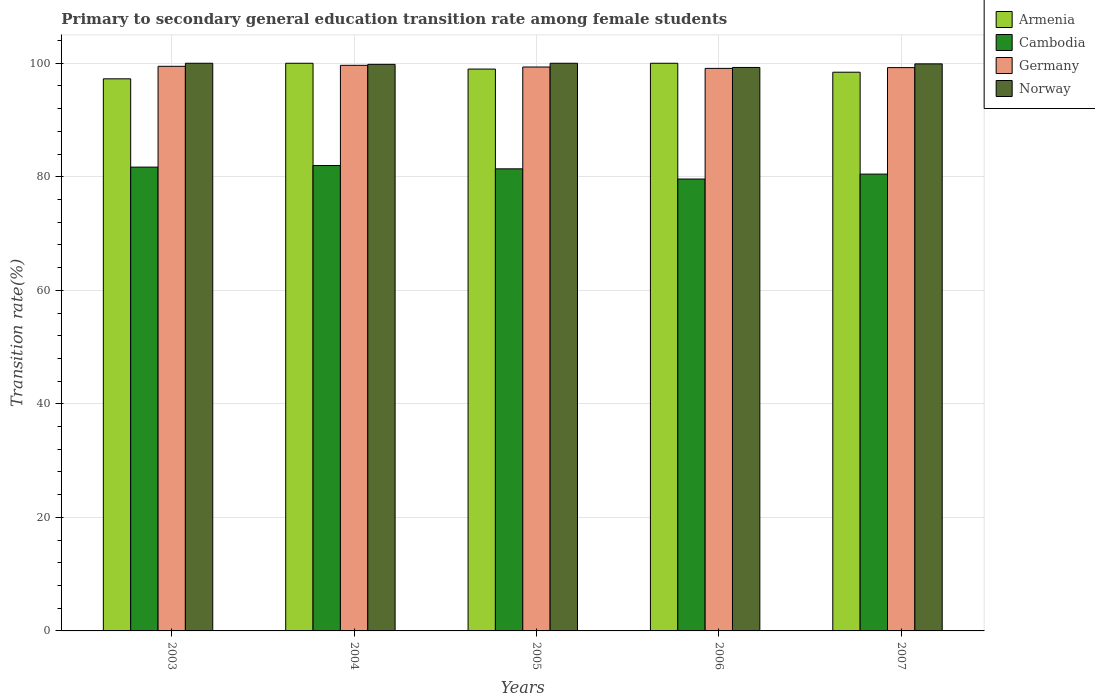How many different coloured bars are there?
Offer a very short reply. 4. How many groups of bars are there?
Offer a very short reply. 5. What is the label of the 5th group of bars from the left?
Your answer should be very brief. 2007. Across all years, what is the minimum transition rate in Cambodia?
Keep it short and to the point. 79.6. In which year was the transition rate in Armenia maximum?
Your response must be concise. 2004. What is the total transition rate in Germany in the graph?
Offer a terse response. 496.77. What is the difference between the transition rate in Armenia in 2006 and that in 2007?
Provide a succinct answer. 1.58. What is the difference between the transition rate in Armenia in 2005 and the transition rate in Norway in 2003?
Provide a short and direct response. -1.03. What is the average transition rate in Norway per year?
Your answer should be compact. 99.79. In the year 2005, what is the difference between the transition rate in Norway and transition rate in Cambodia?
Provide a short and direct response. 18.6. In how many years, is the transition rate in Armenia greater than 40 %?
Make the answer very short. 5. What is the ratio of the transition rate in Germany in 2006 to that in 2007?
Offer a very short reply. 1. Is the transition rate in Cambodia in 2003 less than that in 2005?
Make the answer very short. No. Is the difference between the transition rate in Norway in 2004 and 2005 greater than the difference between the transition rate in Cambodia in 2004 and 2005?
Your response must be concise. No. What is the difference between the highest and the second highest transition rate in Cambodia?
Your answer should be very brief. 0.28. What is the difference between the highest and the lowest transition rate in Germany?
Offer a very short reply. 0.54. In how many years, is the transition rate in Germany greater than the average transition rate in Germany taken over all years?
Ensure brevity in your answer.  2. Is the sum of the transition rate in Germany in 2003 and 2004 greater than the maximum transition rate in Armenia across all years?
Your response must be concise. Yes. Is it the case that in every year, the sum of the transition rate in Armenia and transition rate in Norway is greater than the sum of transition rate in Germany and transition rate in Cambodia?
Offer a very short reply. Yes. What does the 2nd bar from the left in 2004 represents?
Provide a succinct answer. Cambodia. What does the 3rd bar from the right in 2005 represents?
Make the answer very short. Cambodia. Is it the case that in every year, the sum of the transition rate in Norway and transition rate in Germany is greater than the transition rate in Cambodia?
Offer a terse response. Yes. How many bars are there?
Your answer should be compact. 20. Are all the bars in the graph horizontal?
Make the answer very short. No. How many years are there in the graph?
Give a very brief answer. 5. Are the values on the major ticks of Y-axis written in scientific E-notation?
Your answer should be very brief. No. Where does the legend appear in the graph?
Your answer should be very brief. Top right. How are the legend labels stacked?
Your answer should be compact. Vertical. What is the title of the graph?
Your answer should be compact. Primary to secondary general education transition rate among female students. Does "Belize" appear as one of the legend labels in the graph?
Offer a terse response. No. What is the label or title of the Y-axis?
Your answer should be compact. Transition rate(%). What is the Transition rate(%) of Armenia in 2003?
Make the answer very short. 97.26. What is the Transition rate(%) of Cambodia in 2003?
Provide a succinct answer. 81.7. What is the Transition rate(%) of Germany in 2003?
Keep it short and to the point. 99.46. What is the Transition rate(%) of Norway in 2003?
Your answer should be compact. 100. What is the Transition rate(%) in Cambodia in 2004?
Make the answer very short. 81.98. What is the Transition rate(%) of Germany in 2004?
Give a very brief answer. 99.64. What is the Transition rate(%) in Norway in 2004?
Give a very brief answer. 99.81. What is the Transition rate(%) of Armenia in 2005?
Make the answer very short. 98.97. What is the Transition rate(%) of Cambodia in 2005?
Ensure brevity in your answer.  81.4. What is the Transition rate(%) in Germany in 2005?
Your answer should be compact. 99.34. What is the Transition rate(%) in Norway in 2005?
Provide a succinct answer. 100. What is the Transition rate(%) of Armenia in 2006?
Your response must be concise. 100. What is the Transition rate(%) of Cambodia in 2006?
Offer a very short reply. 79.6. What is the Transition rate(%) in Germany in 2006?
Provide a short and direct response. 99.1. What is the Transition rate(%) in Norway in 2006?
Offer a terse response. 99.26. What is the Transition rate(%) of Armenia in 2007?
Your answer should be very brief. 98.42. What is the Transition rate(%) of Cambodia in 2007?
Make the answer very short. 80.47. What is the Transition rate(%) of Germany in 2007?
Your answer should be very brief. 99.23. What is the Transition rate(%) of Norway in 2007?
Ensure brevity in your answer.  99.89. Across all years, what is the maximum Transition rate(%) in Cambodia?
Provide a short and direct response. 81.98. Across all years, what is the maximum Transition rate(%) of Germany?
Give a very brief answer. 99.64. Across all years, what is the maximum Transition rate(%) of Norway?
Make the answer very short. 100. Across all years, what is the minimum Transition rate(%) in Armenia?
Offer a very short reply. 97.26. Across all years, what is the minimum Transition rate(%) of Cambodia?
Your answer should be very brief. 79.6. Across all years, what is the minimum Transition rate(%) in Germany?
Offer a terse response. 99.1. Across all years, what is the minimum Transition rate(%) in Norway?
Provide a short and direct response. 99.26. What is the total Transition rate(%) of Armenia in the graph?
Provide a succinct answer. 494.66. What is the total Transition rate(%) of Cambodia in the graph?
Ensure brevity in your answer.  405.17. What is the total Transition rate(%) of Germany in the graph?
Your answer should be compact. 496.77. What is the total Transition rate(%) in Norway in the graph?
Provide a succinct answer. 498.96. What is the difference between the Transition rate(%) in Armenia in 2003 and that in 2004?
Keep it short and to the point. -2.74. What is the difference between the Transition rate(%) of Cambodia in 2003 and that in 2004?
Offer a very short reply. -0.28. What is the difference between the Transition rate(%) of Germany in 2003 and that in 2004?
Provide a succinct answer. -0.18. What is the difference between the Transition rate(%) in Norway in 2003 and that in 2004?
Your answer should be very brief. 0.19. What is the difference between the Transition rate(%) of Armenia in 2003 and that in 2005?
Give a very brief answer. -1.72. What is the difference between the Transition rate(%) in Cambodia in 2003 and that in 2005?
Offer a very short reply. 0.3. What is the difference between the Transition rate(%) in Germany in 2003 and that in 2005?
Offer a terse response. 0.12. What is the difference between the Transition rate(%) of Armenia in 2003 and that in 2006?
Your answer should be compact. -2.74. What is the difference between the Transition rate(%) in Cambodia in 2003 and that in 2006?
Make the answer very short. 2.1. What is the difference between the Transition rate(%) in Germany in 2003 and that in 2006?
Provide a succinct answer. 0.36. What is the difference between the Transition rate(%) of Norway in 2003 and that in 2006?
Offer a very short reply. 0.74. What is the difference between the Transition rate(%) of Armenia in 2003 and that in 2007?
Offer a terse response. -1.17. What is the difference between the Transition rate(%) in Cambodia in 2003 and that in 2007?
Ensure brevity in your answer.  1.23. What is the difference between the Transition rate(%) of Germany in 2003 and that in 2007?
Offer a very short reply. 0.23. What is the difference between the Transition rate(%) of Norway in 2003 and that in 2007?
Provide a short and direct response. 0.11. What is the difference between the Transition rate(%) of Armenia in 2004 and that in 2005?
Provide a succinct answer. 1.03. What is the difference between the Transition rate(%) in Cambodia in 2004 and that in 2005?
Offer a terse response. 0.58. What is the difference between the Transition rate(%) of Germany in 2004 and that in 2005?
Offer a very short reply. 0.3. What is the difference between the Transition rate(%) in Norway in 2004 and that in 2005?
Give a very brief answer. -0.19. What is the difference between the Transition rate(%) in Cambodia in 2004 and that in 2006?
Your response must be concise. 2.38. What is the difference between the Transition rate(%) of Germany in 2004 and that in 2006?
Provide a short and direct response. 0.54. What is the difference between the Transition rate(%) of Norway in 2004 and that in 2006?
Make the answer very short. 0.55. What is the difference between the Transition rate(%) in Armenia in 2004 and that in 2007?
Make the answer very short. 1.58. What is the difference between the Transition rate(%) of Cambodia in 2004 and that in 2007?
Provide a short and direct response. 1.51. What is the difference between the Transition rate(%) in Germany in 2004 and that in 2007?
Keep it short and to the point. 0.41. What is the difference between the Transition rate(%) of Norway in 2004 and that in 2007?
Make the answer very short. -0.09. What is the difference between the Transition rate(%) in Armenia in 2005 and that in 2006?
Your answer should be very brief. -1.03. What is the difference between the Transition rate(%) in Cambodia in 2005 and that in 2006?
Your response must be concise. 1.8. What is the difference between the Transition rate(%) in Germany in 2005 and that in 2006?
Your response must be concise. 0.24. What is the difference between the Transition rate(%) in Norway in 2005 and that in 2006?
Provide a succinct answer. 0.74. What is the difference between the Transition rate(%) of Armenia in 2005 and that in 2007?
Provide a succinct answer. 0.55. What is the difference between the Transition rate(%) of Cambodia in 2005 and that in 2007?
Give a very brief answer. 0.93. What is the difference between the Transition rate(%) of Germany in 2005 and that in 2007?
Ensure brevity in your answer.  0.11. What is the difference between the Transition rate(%) in Norway in 2005 and that in 2007?
Give a very brief answer. 0.11. What is the difference between the Transition rate(%) of Armenia in 2006 and that in 2007?
Provide a succinct answer. 1.58. What is the difference between the Transition rate(%) in Cambodia in 2006 and that in 2007?
Give a very brief answer. -0.87. What is the difference between the Transition rate(%) of Germany in 2006 and that in 2007?
Give a very brief answer. -0.13. What is the difference between the Transition rate(%) of Norway in 2006 and that in 2007?
Offer a terse response. -0.63. What is the difference between the Transition rate(%) in Armenia in 2003 and the Transition rate(%) in Cambodia in 2004?
Ensure brevity in your answer.  15.27. What is the difference between the Transition rate(%) of Armenia in 2003 and the Transition rate(%) of Germany in 2004?
Provide a short and direct response. -2.38. What is the difference between the Transition rate(%) in Armenia in 2003 and the Transition rate(%) in Norway in 2004?
Your response must be concise. -2.55. What is the difference between the Transition rate(%) of Cambodia in 2003 and the Transition rate(%) of Germany in 2004?
Keep it short and to the point. -17.93. What is the difference between the Transition rate(%) in Cambodia in 2003 and the Transition rate(%) in Norway in 2004?
Your answer should be compact. -18.1. What is the difference between the Transition rate(%) in Germany in 2003 and the Transition rate(%) in Norway in 2004?
Your answer should be compact. -0.35. What is the difference between the Transition rate(%) in Armenia in 2003 and the Transition rate(%) in Cambodia in 2005?
Make the answer very short. 15.86. What is the difference between the Transition rate(%) of Armenia in 2003 and the Transition rate(%) of Germany in 2005?
Keep it short and to the point. -2.08. What is the difference between the Transition rate(%) of Armenia in 2003 and the Transition rate(%) of Norway in 2005?
Ensure brevity in your answer.  -2.74. What is the difference between the Transition rate(%) of Cambodia in 2003 and the Transition rate(%) of Germany in 2005?
Offer a very short reply. -17.64. What is the difference between the Transition rate(%) in Cambodia in 2003 and the Transition rate(%) in Norway in 2005?
Offer a terse response. -18.3. What is the difference between the Transition rate(%) of Germany in 2003 and the Transition rate(%) of Norway in 2005?
Provide a succinct answer. -0.54. What is the difference between the Transition rate(%) of Armenia in 2003 and the Transition rate(%) of Cambodia in 2006?
Your response must be concise. 17.65. What is the difference between the Transition rate(%) in Armenia in 2003 and the Transition rate(%) in Germany in 2006?
Your answer should be very brief. -1.84. What is the difference between the Transition rate(%) of Armenia in 2003 and the Transition rate(%) of Norway in 2006?
Ensure brevity in your answer.  -2. What is the difference between the Transition rate(%) of Cambodia in 2003 and the Transition rate(%) of Germany in 2006?
Ensure brevity in your answer.  -17.4. What is the difference between the Transition rate(%) of Cambodia in 2003 and the Transition rate(%) of Norway in 2006?
Give a very brief answer. -17.56. What is the difference between the Transition rate(%) in Germany in 2003 and the Transition rate(%) in Norway in 2006?
Give a very brief answer. 0.2. What is the difference between the Transition rate(%) in Armenia in 2003 and the Transition rate(%) in Cambodia in 2007?
Provide a succinct answer. 16.79. What is the difference between the Transition rate(%) of Armenia in 2003 and the Transition rate(%) of Germany in 2007?
Make the answer very short. -1.97. What is the difference between the Transition rate(%) in Armenia in 2003 and the Transition rate(%) in Norway in 2007?
Ensure brevity in your answer.  -2.63. What is the difference between the Transition rate(%) of Cambodia in 2003 and the Transition rate(%) of Germany in 2007?
Offer a terse response. -17.53. What is the difference between the Transition rate(%) of Cambodia in 2003 and the Transition rate(%) of Norway in 2007?
Give a very brief answer. -18.19. What is the difference between the Transition rate(%) in Germany in 2003 and the Transition rate(%) in Norway in 2007?
Give a very brief answer. -0.43. What is the difference between the Transition rate(%) of Armenia in 2004 and the Transition rate(%) of Cambodia in 2005?
Your answer should be very brief. 18.6. What is the difference between the Transition rate(%) in Armenia in 2004 and the Transition rate(%) in Germany in 2005?
Your answer should be compact. 0.66. What is the difference between the Transition rate(%) in Cambodia in 2004 and the Transition rate(%) in Germany in 2005?
Offer a terse response. -17.36. What is the difference between the Transition rate(%) of Cambodia in 2004 and the Transition rate(%) of Norway in 2005?
Make the answer very short. -18.02. What is the difference between the Transition rate(%) of Germany in 2004 and the Transition rate(%) of Norway in 2005?
Make the answer very short. -0.36. What is the difference between the Transition rate(%) of Armenia in 2004 and the Transition rate(%) of Cambodia in 2006?
Your answer should be compact. 20.4. What is the difference between the Transition rate(%) in Armenia in 2004 and the Transition rate(%) in Germany in 2006?
Offer a very short reply. 0.9. What is the difference between the Transition rate(%) in Armenia in 2004 and the Transition rate(%) in Norway in 2006?
Your answer should be very brief. 0.74. What is the difference between the Transition rate(%) in Cambodia in 2004 and the Transition rate(%) in Germany in 2006?
Provide a succinct answer. -17.11. What is the difference between the Transition rate(%) of Cambodia in 2004 and the Transition rate(%) of Norway in 2006?
Your response must be concise. -17.28. What is the difference between the Transition rate(%) in Germany in 2004 and the Transition rate(%) in Norway in 2006?
Offer a very short reply. 0.38. What is the difference between the Transition rate(%) in Armenia in 2004 and the Transition rate(%) in Cambodia in 2007?
Ensure brevity in your answer.  19.53. What is the difference between the Transition rate(%) in Armenia in 2004 and the Transition rate(%) in Germany in 2007?
Offer a terse response. 0.77. What is the difference between the Transition rate(%) of Armenia in 2004 and the Transition rate(%) of Norway in 2007?
Offer a terse response. 0.11. What is the difference between the Transition rate(%) of Cambodia in 2004 and the Transition rate(%) of Germany in 2007?
Your response must be concise. -17.25. What is the difference between the Transition rate(%) in Cambodia in 2004 and the Transition rate(%) in Norway in 2007?
Your answer should be very brief. -17.91. What is the difference between the Transition rate(%) of Germany in 2004 and the Transition rate(%) of Norway in 2007?
Offer a terse response. -0.26. What is the difference between the Transition rate(%) of Armenia in 2005 and the Transition rate(%) of Cambodia in 2006?
Your response must be concise. 19.37. What is the difference between the Transition rate(%) of Armenia in 2005 and the Transition rate(%) of Germany in 2006?
Offer a very short reply. -0.12. What is the difference between the Transition rate(%) of Armenia in 2005 and the Transition rate(%) of Norway in 2006?
Your answer should be very brief. -0.28. What is the difference between the Transition rate(%) of Cambodia in 2005 and the Transition rate(%) of Germany in 2006?
Keep it short and to the point. -17.7. What is the difference between the Transition rate(%) in Cambodia in 2005 and the Transition rate(%) in Norway in 2006?
Ensure brevity in your answer.  -17.86. What is the difference between the Transition rate(%) of Germany in 2005 and the Transition rate(%) of Norway in 2006?
Your response must be concise. 0.08. What is the difference between the Transition rate(%) of Armenia in 2005 and the Transition rate(%) of Cambodia in 2007?
Provide a succinct answer. 18.5. What is the difference between the Transition rate(%) in Armenia in 2005 and the Transition rate(%) in Germany in 2007?
Provide a short and direct response. -0.26. What is the difference between the Transition rate(%) of Armenia in 2005 and the Transition rate(%) of Norway in 2007?
Your response must be concise. -0.92. What is the difference between the Transition rate(%) in Cambodia in 2005 and the Transition rate(%) in Germany in 2007?
Offer a terse response. -17.83. What is the difference between the Transition rate(%) of Cambodia in 2005 and the Transition rate(%) of Norway in 2007?
Your response must be concise. -18.49. What is the difference between the Transition rate(%) in Germany in 2005 and the Transition rate(%) in Norway in 2007?
Your answer should be compact. -0.55. What is the difference between the Transition rate(%) of Armenia in 2006 and the Transition rate(%) of Cambodia in 2007?
Make the answer very short. 19.53. What is the difference between the Transition rate(%) in Armenia in 2006 and the Transition rate(%) in Germany in 2007?
Your answer should be very brief. 0.77. What is the difference between the Transition rate(%) of Armenia in 2006 and the Transition rate(%) of Norway in 2007?
Make the answer very short. 0.11. What is the difference between the Transition rate(%) in Cambodia in 2006 and the Transition rate(%) in Germany in 2007?
Provide a short and direct response. -19.63. What is the difference between the Transition rate(%) of Cambodia in 2006 and the Transition rate(%) of Norway in 2007?
Your answer should be very brief. -20.29. What is the difference between the Transition rate(%) in Germany in 2006 and the Transition rate(%) in Norway in 2007?
Keep it short and to the point. -0.79. What is the average Transition rate(%) of Armenia per year?
Offer a terse response. 98.93. What is the average Transition rate(%) of Cambodia per year?
Provide a succinct answer. 81.03. What is the average Transition rate(%) of Germany per year?
Provide a short and direct response. 99.35. What is the average Transition rate(%) in Norway per year?
Provide a succinct answer. 99.79. In the year 2003, what is the difference between the Transition rate(%) of Armenia and Transition rate(%) of Cambodia?
Ensure brevity in your answer.  15.55. In the year 2003, what is the difference between the Transition rate(%) in Armenia and Transition rate(%) in Germany?
Your response must be concise. -2.2. In the year 2003, what is the difference between the Transition rate(%) of Armenia and Transition rate(%) of Norway?
Your answer should be very brief. -2.74. In the year 2003, what is the difference between the Transition rate(%) of Cambodia and Transition rate(%) of Germany?
Keep it short and to the point. -17.76. In the year 2003, what is the difference between the Transition rate(%) of Cambodia and Transition rate(%) of Norway?
Your answer should be very brief. -18.3. In the year 2003, what is the difference between the Transition rate(%) in Germany and Transition rate(%) in Norway?
Offer a terse response. -0.54. In the year 2004, what is the difference between the Transition rate(%) in Armenia and Transition rate(%) in Cambodia?
Provide a succinct answer. 18.02. In the year 2004, what is the difference between the Transition rate(%) of Armenia and Transition rate(%) of Germany?
Ensure brevity in your answer.  0.36. In the year 2004, what is the difference between the Transition rate(%) of Armenia and Transition rate(%) of Norway?
Offer a very short reply. 0.19. In the year 2004, what is the difference between the Transition rate(%) of Cambodia and Transition rate(%) of Germany?
Keep it short and to the point. -17.65. In the year 2004, what is the difference between the Transition rate(%) in Cambodia and Transition rate(%) in Norway?
Your response must be concise. -17.82. In the year 2004, what is the difference between the Transition rate(%) in Germany and Transition rate(%) in Norway?
Your answer should be very brief. -0.17. In the year 2005, what is the difference between the Transition rate(%) of Armenia and Transition rate(%) of Cambodia?
Offer a very short reply. 17.57. In the year 2005, what is the difference between the Transition rate(%) of Armenia and Transition rate(%) of Germany?
Offer a terse response. -0.37. In the year 2005, what is the difference between the Transition rate(%) in Armenia and Transition rate(%) in Norway?
Your answer should be very brief. -1.03. In the year 2005, what is the difference between the Transition rate(%) in Cambodia and Transition rate(%) in Germany?
Provide a succinct answer. -17.94. In the year 2005, what is the difference between the Transition rate(%) of Cambodia and Transition rate(%) of Norway?
Give a very brief answer. -18.6. In the year 2005, what is the difference between the Transition rate(%) in Germany and Transition rate(%) in Norway?
Make the answer very short. -0.66. In the year 2006, what is the difference between the Transition rate(%) in Armenia and Transition rate(%) in Cambodia?
Ensure brevity in your answer.  20.4. In the year 2006, what is the difference between the Transition rate(%) of Armenia and Transition rate(%) of Germany?
Provide a short and direct response. 0.9. In the year 2006, what is the difference between the Transition rate(%) in Armenia and Transition rate(%) in Norway?
Offer a terse response. 0.74. In the year 2006, what is the difference between the Transition rate(%) in Cambodia and Transition rate(%) in Germany?
Your answer should be compact. -19.49. In the year 2006, what is the difference between the Transition rate(%) in Cambodia and Transition rate(%) in Norway?
Keep it short and to the point. -19.65. In the year 2006, what is the difference between the Transition rate(%) of Germany and Transition rate(%) of Norway?
Your answer should be very brief. -0.16. In the year 2007, what is the difference between the Transition rate(%) in Armenia and Transition rate(%) in Cambodia?
Provide a succinct answer. 17.95. In the year 2007, what is the difference between the Transition rate(%) in Armenia and Transition rate(%) in Germany?
Provide a short and direct response. -0.81. In the year 2007, what is the difference between the Transition rate(%) in Armenia and Transition rate(%) in Norway?
Provide a succinct answer. -1.47. In the year 2007, what is the difference between the Transition rate(%) in Cambodia and Transition rate(%) in Germany?
Provide a succinct answer. -18.76. In the year 2007, what is the difference between the Transition rate(%) of Cambodia and Transition rate(%) of Norway?
Provide a succinct answer. -19.42. In the year 2007, what is the difference between the Transition rate(%) in Germany and Transition rate(%) in Norway?
Make the answer very short. -0.66. What is the ratio of the Transition rate(%) of Armenia in 2003 to that in 2004?
Your answer should be compact. 0.97. What is the ratio of the Transition rate(%) of Armenia in 2003 to that in 2005?
Ensure brevity in your answer.  0.98. What is the ratio of the Transition rate(%) in Armenia in 2003 to that in 2006?
Provide a short and direct response. 0.97. What is the ratio of the Transition rate(%) in Cambodia in 2003 to that in 2006?
Offer a terse response. 1.03. What is the ratio of the Transition rate(%) of Germany in 2003 to that in 2006?
Give a very brief answer. 1. What is the ratio of the Transition rate(%) in Norway in 2003 to that in 2006?
Make the answer very short. 1.01. What is the ratio of the Transition rate(%) of Armenia in 2003 to that in 2007?
Your answer should be compact. 0.99. What is the ratio of the Transition rate(%) of Cambodia in 2003 to that in 2007?
Ensure brevity in your answer.  1.02. What is the ratio of the Transition rate(%) of Armenia in 2004 to that in 2005?
Your response must be concise. 1.01. What is the ratio of the Transition rate(%) in Cambodia in 2004 to that in 2005?
Make the answer very short. 1.01. What is the ratio of the Transition rate(%) of Cambodia in 2004 to that in 2006?
Keep it short and to the point. 1.03. What is the ratio of the Transition rate(%) of Germany in 2004 to that in 2006?
Ensure brevity in your answer.  1.01. What is the ratio of the Transition rate(%) of Cambodia in 2004 to that in 2007?
Provide a succinct answer. 1.02. What is the ratio of the Transition rate(%) of Cambodia in 2005 to that in 2006?
Your answer should be very brief. 1.02. What is the ratio of the Transition rate(%) of Norway in 2005 to that in 2006?
Ensure brevity in your answer.  1.01. What is the ratio of the Transition rate(%) of Armenia in 2005 to that in 2007?
Offer a terse response. 1.01. What is the ratio of the Transition rate(%) in Cambodia in 2005 to that in 2007?
Your answer should be compact. 1.01. What is the ratio of the Transition rate(%) of Germany in 2005 to that in 2007?
Your answer should be compact. 1. What is the ratio of the Transition rate(%) in Norway in 2005 to that in 2007?
Your answer should be compact. 1. What is the ratio of the Transition rate(%) of Armenia in 2006 to that in 2007?
Your answer should be compact. 1.02. What is the ratio of the Transition rate(%) in Cambodia in 2006 to that in 2007?
Offer a terse response. 0.99. What is the difference between the highest and the second highest Transition rate(%) in Armenia?
Offer a terse response. 0. What is the difference between the highest and the second highest Transition rate(%) of Cambodia?
Your response must be concise. 0.28. What is the difference between the highest and the second highest Transition rate(%) of Germany?
Offer a terse response. 0.18. What is the difference between the highest and the lowest Transition rate(%) in Armenia?
Provide a succinct answer. 2.74. What is the difference between the highest and the lowest Transition rate(%) of Cambodia?
Keep it short and to the point. 2.38. What is the difference between the highest and the lowest Transition rate(%) in Germany?
Give a very brief answer. 0.54. What is the difference between the highest and the lowest Transition rate(%) of Norway?
Provide a succinct answer. 0.74. 